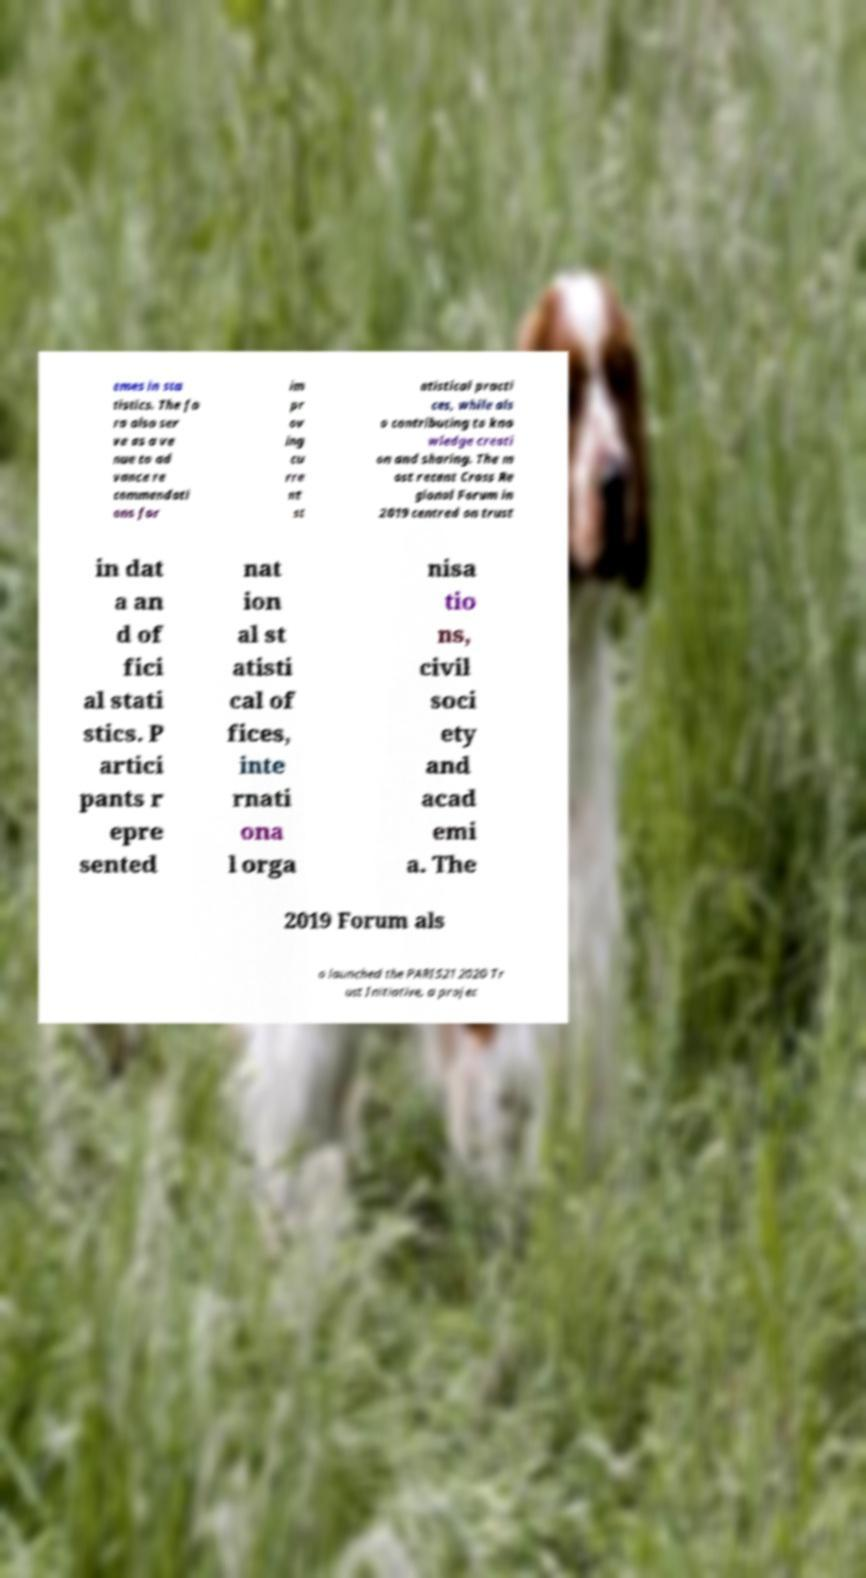For documentation purposes, I need the text within this image transcribed. Could you provide that? emes in sta tistics. The fo ra also ser ve as a ve nue to ad vance re commendati ons for im pr ov ing cu rre nt st atistical practi ces, while als o contributing to kno wledge creati on and sharing. The m ost recent Cross Re gional Forum in 2019 centred on trust in dat a an d of fici al stati stics. P artici pants r epre sented nat ion al st atisti cal of fices, inte rnati ona l orga nisa tio ns, civil soci ety and acad emi a. The 2019 Forum als o launched the PARIS21 2020 Tr ust Initiative, a projec 